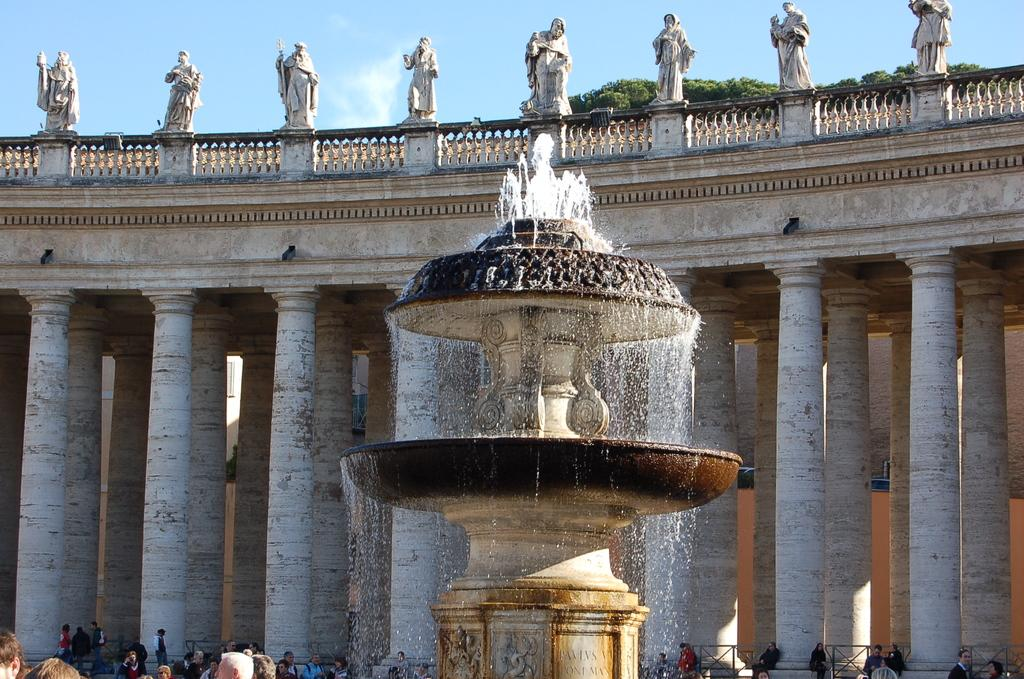What is the main feature in the image? There is a fountain in the image. What is flowing from the fountain? There is water in the image. What architectural elements can be seen around the fountain? There are pillars in the image. Are there any sculptures in the image? Yes, there are statues in the image. What type of vegetation is present in the image? There are trees in the image. What else can be seen in the image besides the fountain and its surroundings? There are some objects and a group of people in the image. What can be seen in the background of the image? The sky is visible in the background of the image. What type of pump is used to circulate the water in the fountain? There is no mention of a pump in the image. 